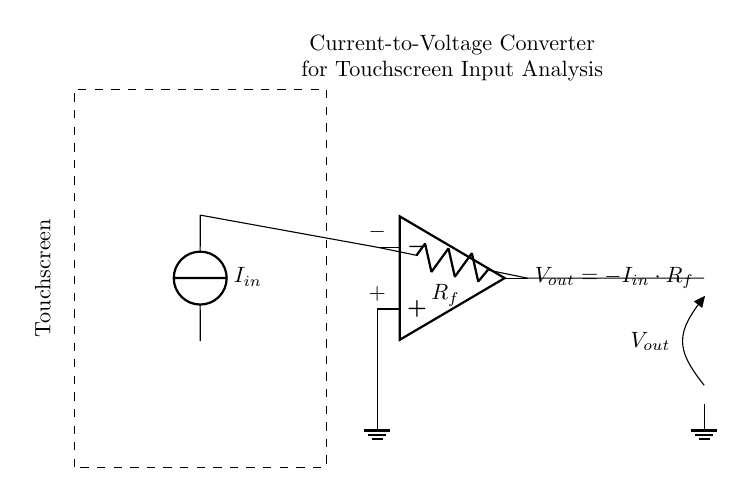What is the input current represented in this circuit? The input current is represented by the current source labeled 'I_in' which indicates the variable input current to the circuit.
Answer: I_in What type of operational amplifier configuration is used here? The operational amplifier is configured as a current-to-voltage converter, also known as a transimpedance amplifier. It converts input current into a proportional output voltage.
Answer: Current-to-voltage converter What does V_out depend on in this circuit? V_out depends on the input current I_in and the feedback resistor R_f, following the relationship V_out = -I_in multiplied by R_f.
Answer: -I_in * R_f Where is the feedback resistor located in this circuit? The feedback resistor R_f is connected between the output of the op-amp and the inverting input terminal, forming a feedback loop that defines the gain of the amplifier.
Answer: Between op-amp output and inverting input What is the function of the ground connection in this circuit? The ground connection serves as a reference point for the circuit; it completes the circuit and stabilizes the voltage levels, ensuring consistent operation of the op-amp.
Answer: Reference point How does this circuit analyze user input patterns in touchscreens? This circuit converts the varying input current from touch interactions into a corresponding output voltage that can be analyzed to detect and interpret user behavior patterns on touchscreens.
Answer: Converts input current to output voltage for analysis 